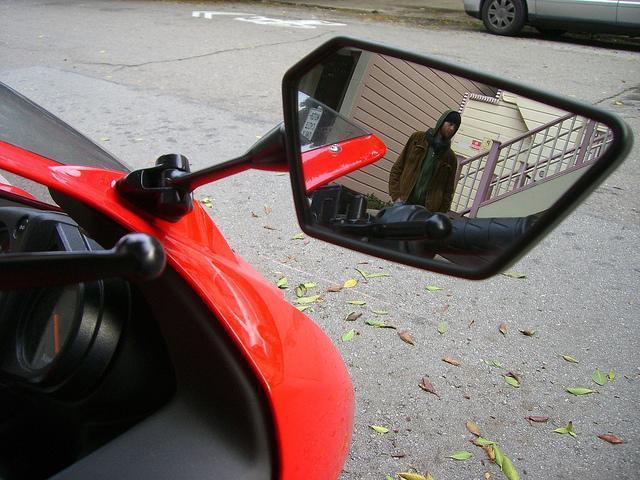How many men are there?
Give a very brief answer. 1. How many bikes are there?
Give a very brief answer. 0. 